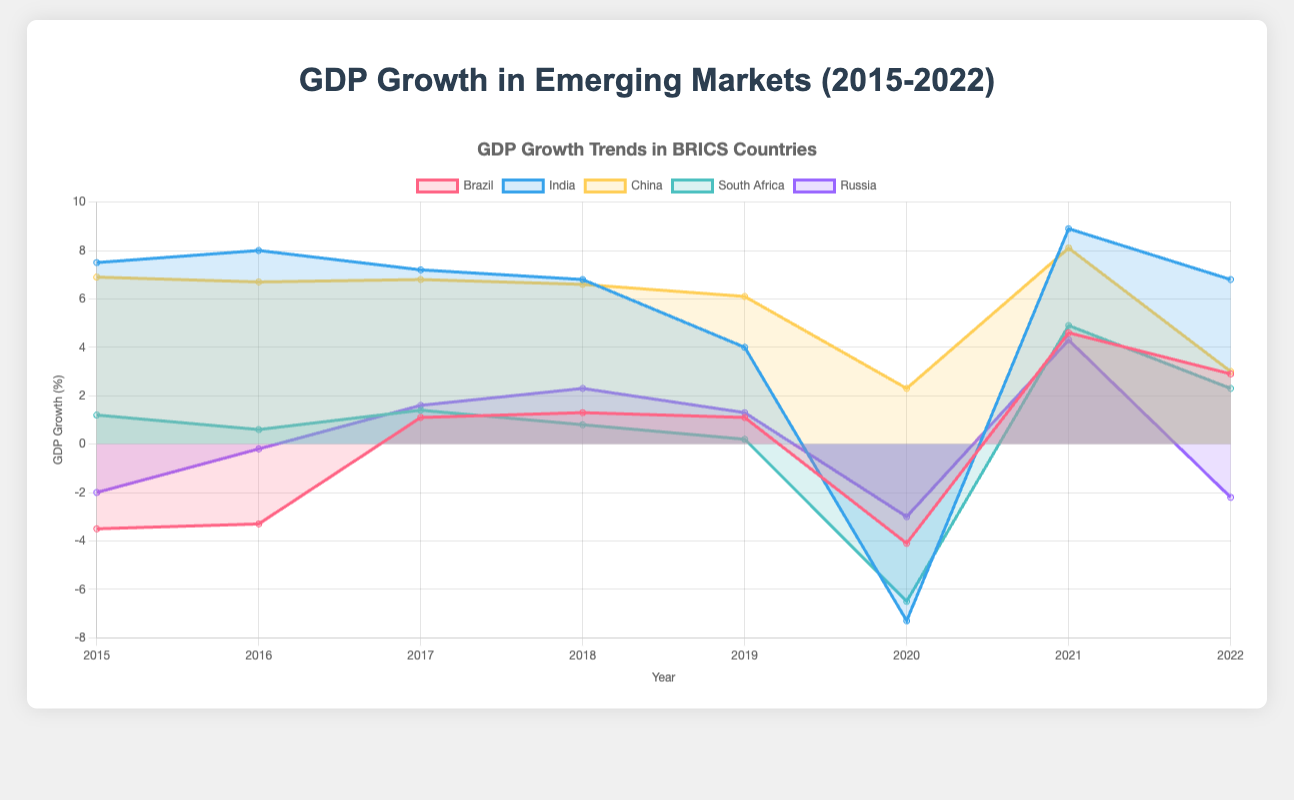What is the title of the chart? The title can be found at the top of the chart. It is typically written in larger and bolder text than other text on the chart.
Answer: "GDP Growth Trends in BRICS Countries" What is the range of the y-axis in the chart? The y-axis range is indicated on the side of the chart, showing the minimum and maximum values. Inspect the y-axis to find the lower and upper bounds.
Answer: -8 to 10 How did Brazil's GDP growth rate change from 2015 to 2016? Look at the data points for Brazil in the years 2015 and 2016. The GDP growth rate went from -3.5% to -3.3%. Subtract the initial year value from the latter year value to find the change.
Answer: Increased by 0.2% Which country had the highest GDP growth rate in 2016, and what was the rate? Check the data points for all countries in the year 2016 and compare the values. The country with the highest value is India, which had a GDP growth rate of 8.0%.
Answer: India, 8.0% In which year did China experience the lowest GDP growth rate, and what was the rate? Review the data for China across all years and identify the year with the smallest GDP growth rate. For China, the lowest rate was in 2022 with a rate of 3.0%.
Answer: 2022, 3.0% Compare the GDP growth trends of Russia and South Africa in 2020. Examine the data points for both countries in 2020. In that year, Russia's GDP growth rate was -3.0%, and South Africa's was -6.5%.
Answer: Russia: -3.0%, South Africa: -6.5% How did the GDP growth of India evolve from 2015 to 2022? Trace the data points for India over the years: 2015 (7.5%), 2016 (8.0%), 2017 (7.2%), 2018 (6.8%), 2019 (4.0%), 2020 (-7.3%), 2021 (8.9%), 2022 (6.8%).
Answer: Fluctuated, with a peak in 2016 (8.0%) and a trough in 2020 (-7.3%) What is the average GDP growth rate for Brazil from 2018 to 2022? To calculate the average, sum the GDP growth rates for Brazil from 2018 to 2022 (1.3%, 1.1%, -4.1%, 4.6%, 2.9%) and divide by the number of years (5). Average = (1.3 + 1.1 - 4.1 + 4.6 + 2.9) / 5.
Answer: 1.16% During which years did South Africa have a GDP growth rate above 1%? Check the data points for South Africa and identify the years with growth rates greater than 1%: 2015 (1.2%), 2017 (1.4%), 2021 (4.9%), 2022 (2.3%).
Answer: 2015, 2017, 2021, 2022 Which country exhibited the widest range in GDP growth rates from 2015 to 2022? Examine the range for each country by finding the difference between the maximum and minimum GDP growth rates. India's range is the largest: max (8.9% in 2021) and min (-7.3% in 2020), for a range of 16.2%.
Answer: India 